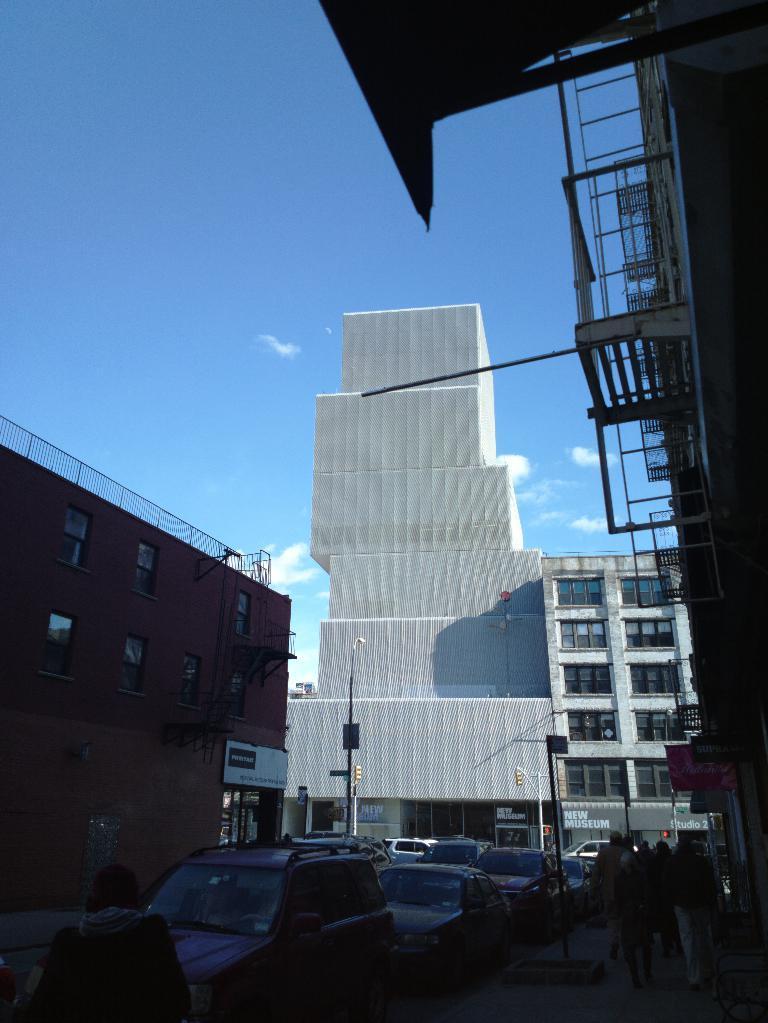Describe this image in one or two sentences. In this image at the bottom we can see vehicles and few persons are on the road. In the background we can see buildings, poles, traffic signal poles, buildings, windows, doors, objects and clouds in the sky. 